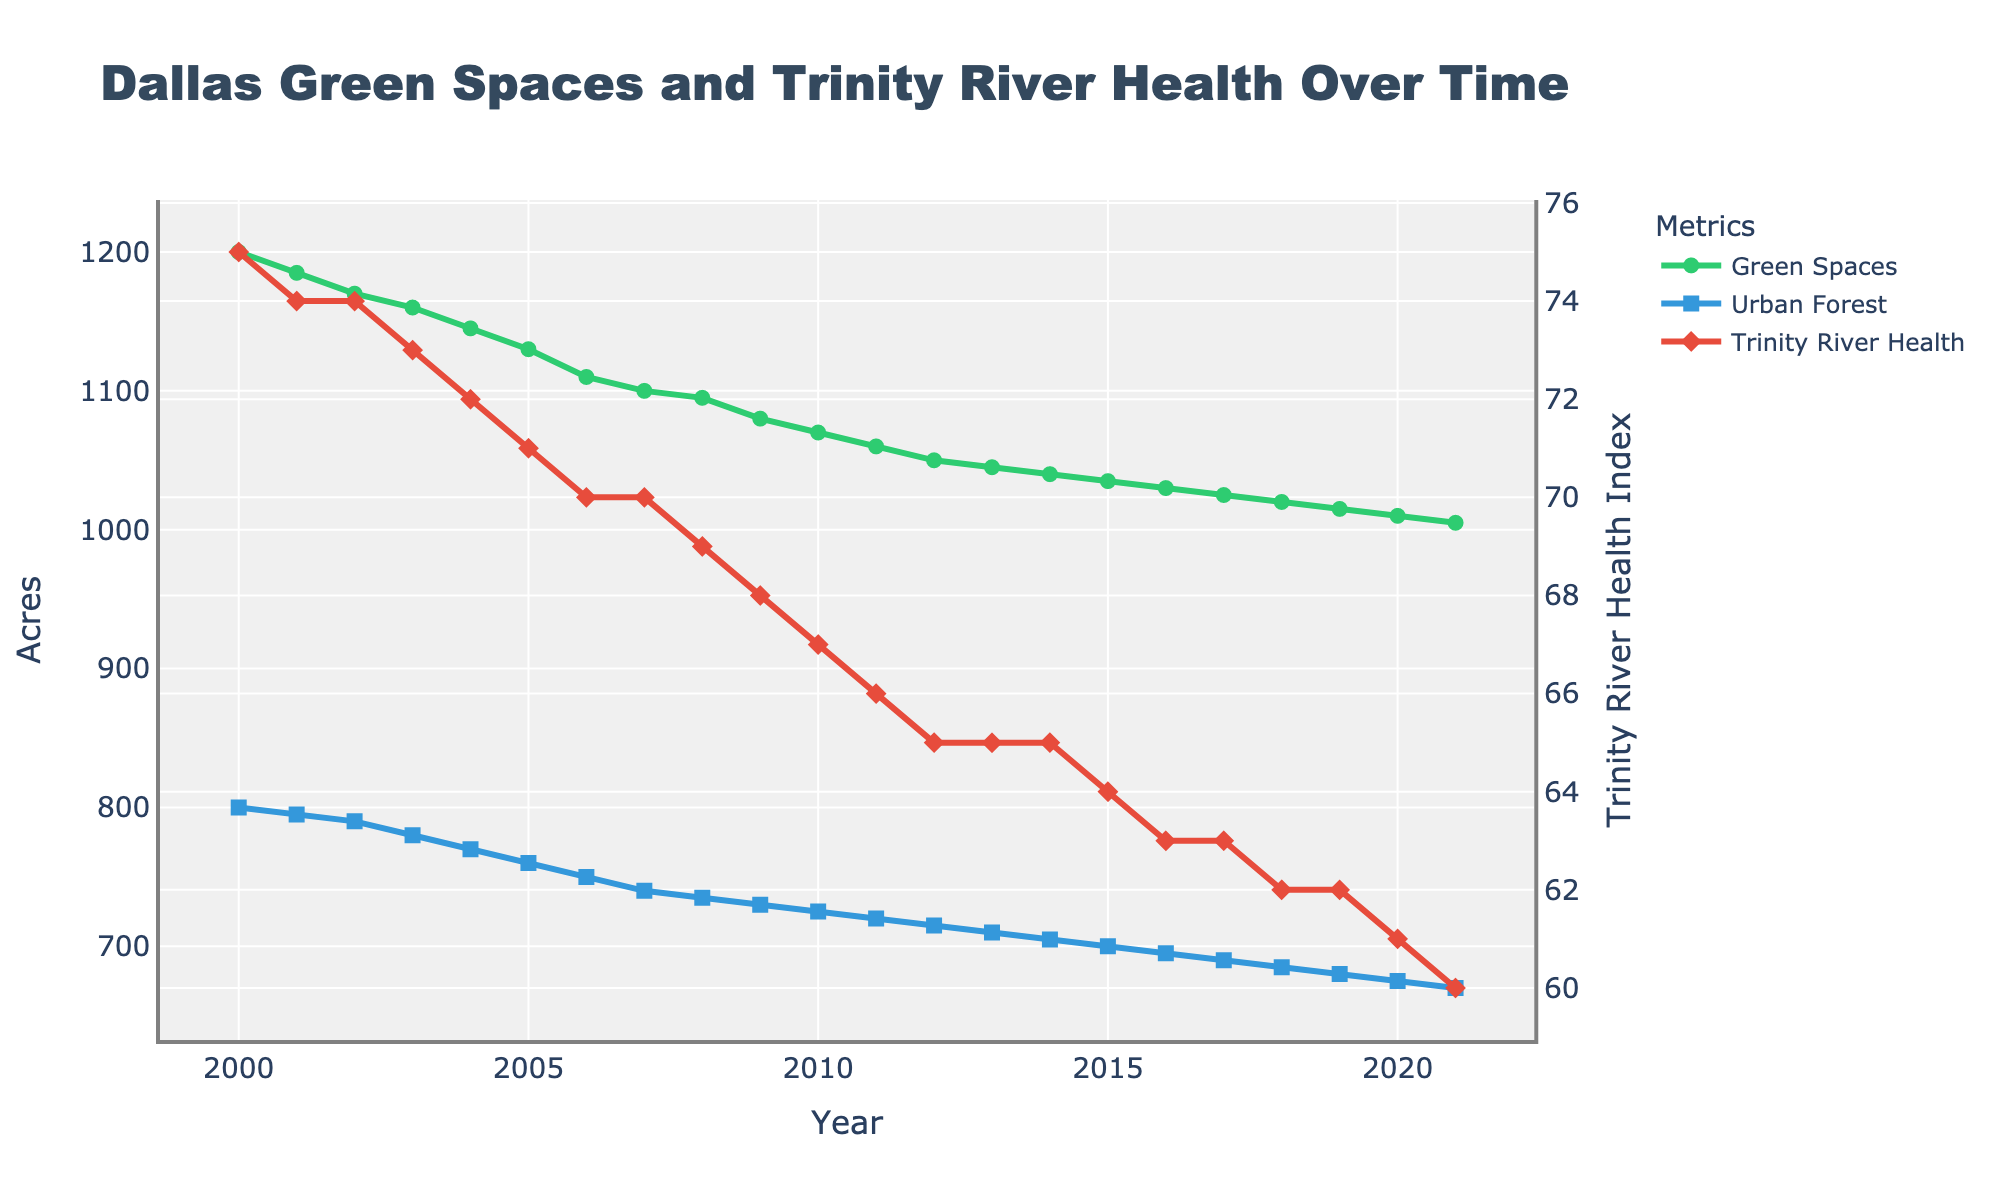what is the title of the figure? The title of the figure is located at the top center and can be read directly.
Answer: Dallas Green Spaces and Trinity River Health Over Time How many acres of Green Spaces were there in Dallas in the year 2010? Look at the data points on the Green Spaces line plot and identify the one corresponding to the year 2010. The y-axis value gives the answer.
Answer: 1070 acres How has the Trinity River Area Health Index changed from 2000 to 2021? Identify the Trinity River Health line plot, then compare the index at 2000 and 2021 by looking at the start and end points of the red line with diamond markers.
Answer: Decreased from 75 to 60 By how many acres has the Urban Forest in Dallas decreased from 2000 to 2021? Find the starting value in 2000 and the ending value in 2021 for the Urban Forest line plot, then calculate the difference between them.
Answer: Decreased by 130 acres Which year saw the steepest decline in the Trinity River Area Health Index? Observe the red line representing the Trinity River Health and identify the year with the most significant downward slope, indicating the steepest decline in a single year.
Answer: 2005 Between which two consecutive years did the Green Spaces in Acres see the largest drop? Identify two consecutive data points on the Green Spaces line plot with the largest vertical distance between them.
Answer: 2000 to 2001 What is the overall trend for the Urban Forest in Acres over the years? Look at the general direction of the blue line plot representing Urban Forest in Acres. The overall trend can be determined by observing if it primarily slopes upward, downward, or remains flat.
Answer: Downward trend How many years did the Trinity River Health Index remain unchanged, and during which period? Observe the Trinity River Health line for any flat segments where the value remains constant, then count the years in those segments and note the range.
Answer: 3 years, from 2012 to 2014 Compared to 2000, what was the percentage decline in Green Spaces by 2021? Calculate the percentage decline using the formula: ((1200 - 1005) / 1200) * 100.
Answer: Approximately 16.25% 